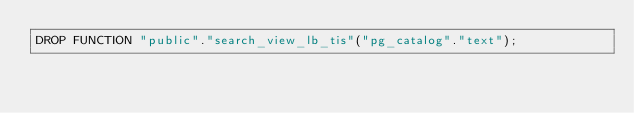<code> <loc_0><loc_0><loc_500><loc_500><_SQL_>DROP FUNCTION "public"."search_view_lb_tis"("pg_catalog"."text");
</code> 